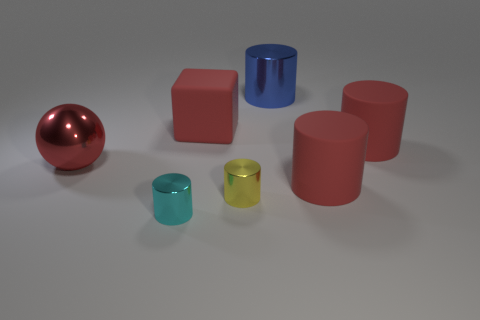Is the number of large shiny objects greater than the number of things?
Your answer should be compact. No. Is there anything else that is the same color as the big block?
Your answer should be compact. Yes. The yellow thing that is made of the same material as the big sphere is what size?
Your answer should be compact. Small. What is the cyan thing made of?
Give a very brief answer. Metal. What number of cyan things are the same size as the blue object?
Keep it short and to the point. 0. What shape is the big metallic object that is the same color as the big block?
Ensure brevity in your answer.  Sphere. Is there a big blue thing of the same shape as the small yellow metallic object?
Your answer should be compact. Yes. The block that is the same size as the red shiny ball is what color?
Your response must be concise. Red. There is a metallic object that is behind the big object that is left of the small cyan shiny object; what is its color?
Provide a short and direct response. Blue. There is a matte cylinder that is in front of the big sphere; is its color the same as the large shiny cylinder?
Provide a short and direct response. No. 